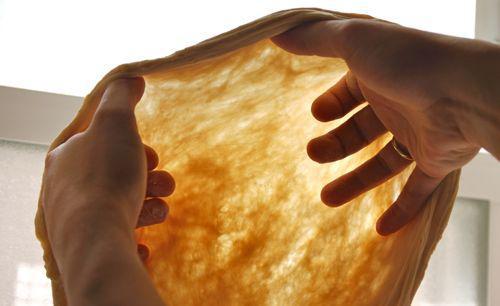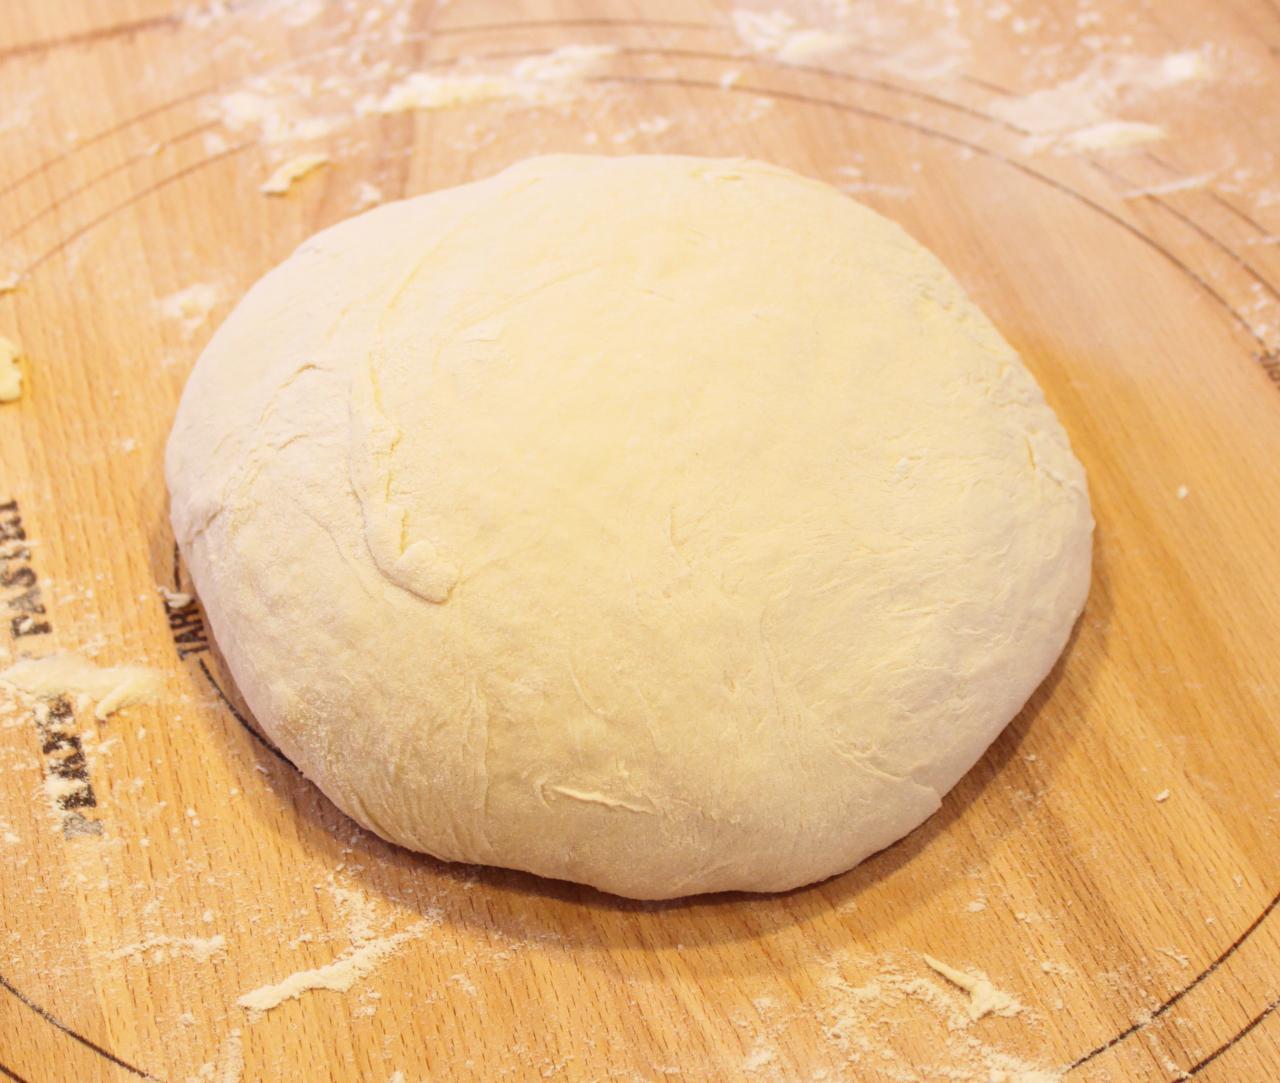The first image is the image on the left, the second image is the image on the right. Examine the images to the left and right. Is the description "A person has their hands in the dough in one picture but not the other." accurate? Answer yes or no. Yes. The first image is the image on the left, the second image is the image on the right. Examine the images to the left and right. Is the description "Dough is rolled into a round ball in the image on the right." accurate? Answer yes or no. Yes. 